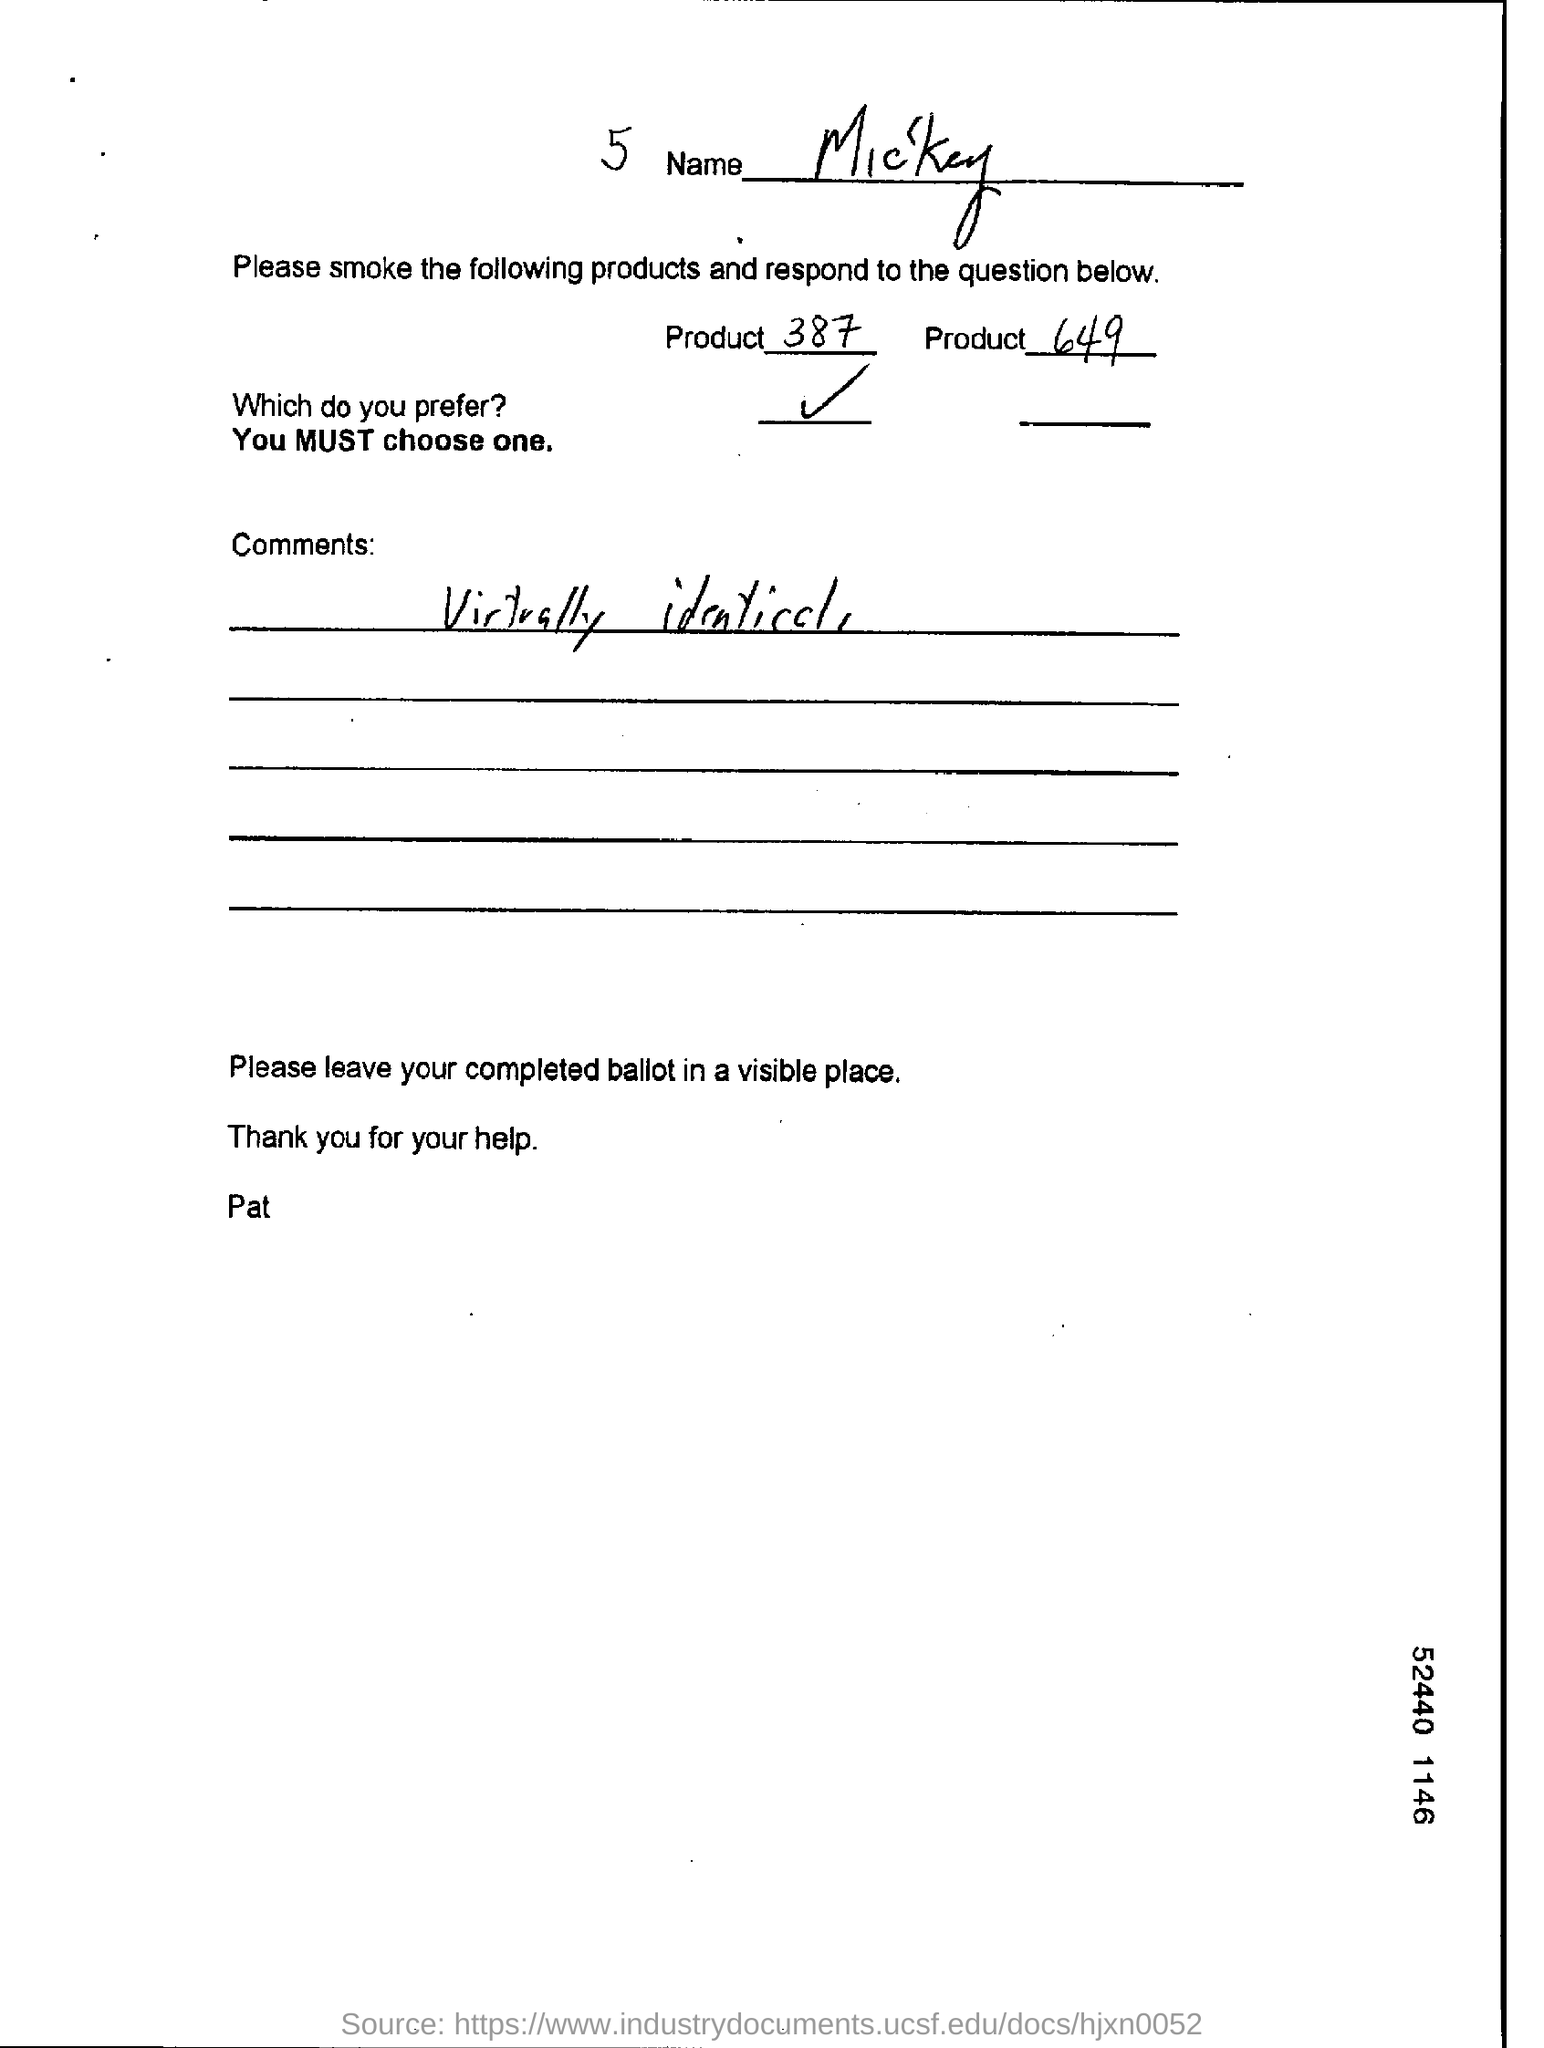What is the name given?
Provide a succinct answer. Mickey. Which product does Mickey prefer?
Keep it short and to the point. 387. What is the comment written?
Offer a very short reply. Virtually identical. Who has signed the form?
Offer a terse response. Pat. 